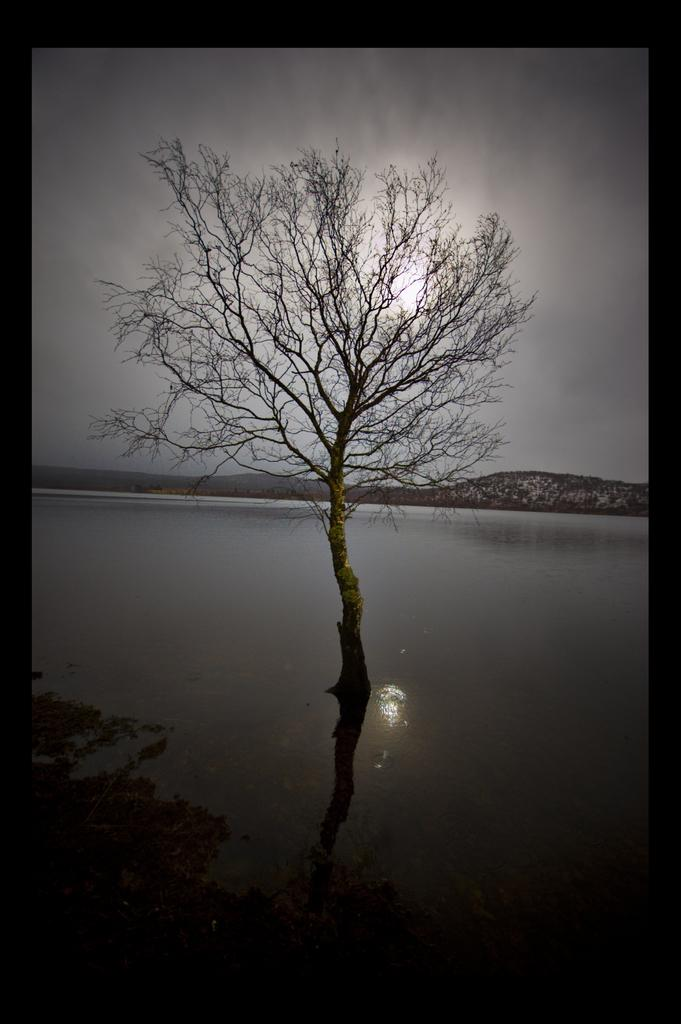What is present in the image? There is a tree in the image. Can you describe the location of the tree? The tree is partially in water. What type of drum can be seen in the image? There is no drum present in the image; it only features a tree partially in water. 